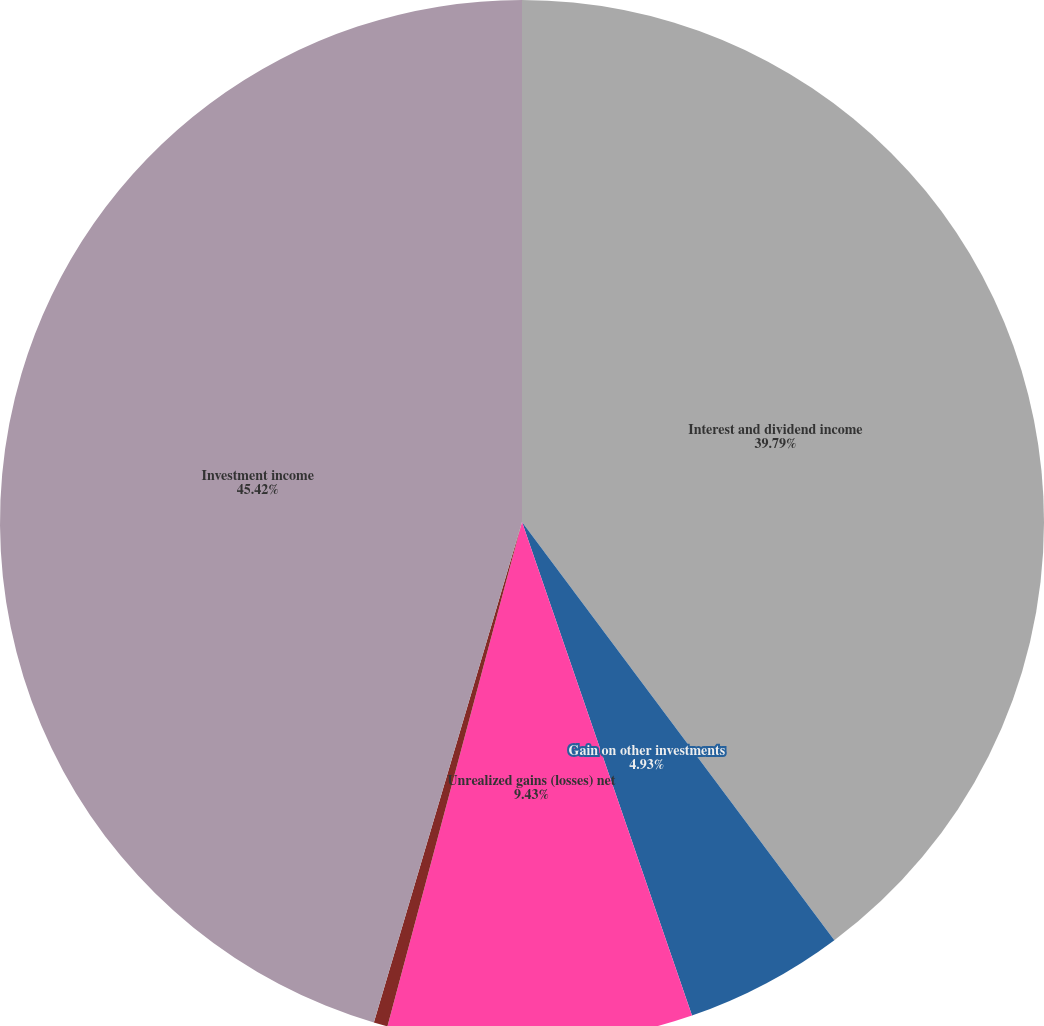Convert chart to OTSL. <chart><loc_0><loc_0><loc_500><loc_500><pie_chart><fcel>Interest and dividend income<fcel>Gain on other investments<fcel>Unrealized gains (losses) net<fcel>Realized (losses) gains net<fcel>Investment income<nl><fcel>39.79%<fcel>4.93%<fcel>9.43%<fcel>0.43%<fcel>45.42%<nl></chart> 